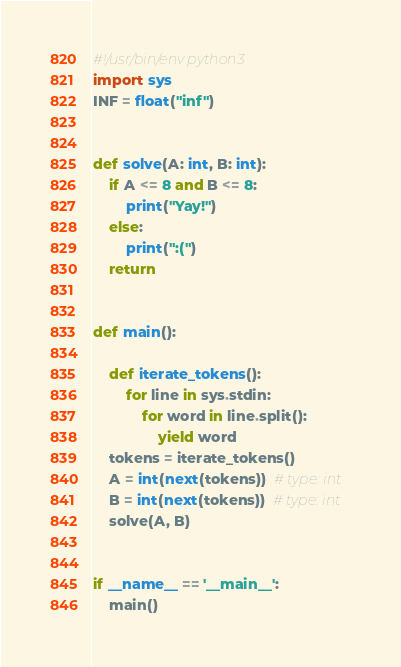<code> <loc_0><loc_0><loc_500><loc_500><_Python_>#!/usr/bin/env python3
import sys
INF = float("inf")


def solve(A: int, B: int):
    if A <= 8 and B <= 8:
        print("Yay!")
    else:
        print(":(")
    return


def main():

    def iterate_tokens():
        for line in sys.stdin:
            for word in line.split():
                yield word
    tokens = iterate_tokens()
    A = int(next(tokens))  # type: int
    B = int(next(tokens))  # type: int
    solve(A, B)


if __name__ == '__main__':
    main()
</code> 